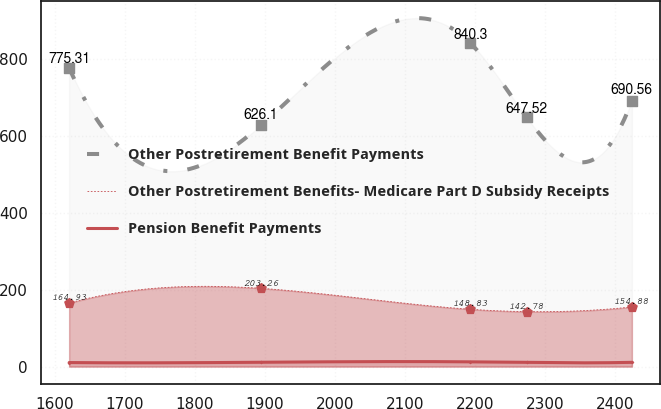<chart> <loc_0><loc_0><loc_500><loc_500><line_chart><ecel><fcel>Other Postretirement Benefit Payments<fcel>Other Postretirement Benefits- Medicare Part D Subsidy Receipts<fcel>Pension Benefit Payments<nl><fcel>1620.52<fcel>775.31<fcel>164.93<fcel>10.48<nl><fcel>1894.11<fcel>626.1<fcel>203.26<fcel>11.26<nl><fcel>2193.51<fcel>840.3<fcel>148.83<fcel>12.33<nl><fcel>2273.9<fcel>647.52<fcel>142.78<fcel>10.74<nl><fcel>2424.42<fcel>690.56<fcel>154.88<fcel>11.07<nl></chart> 